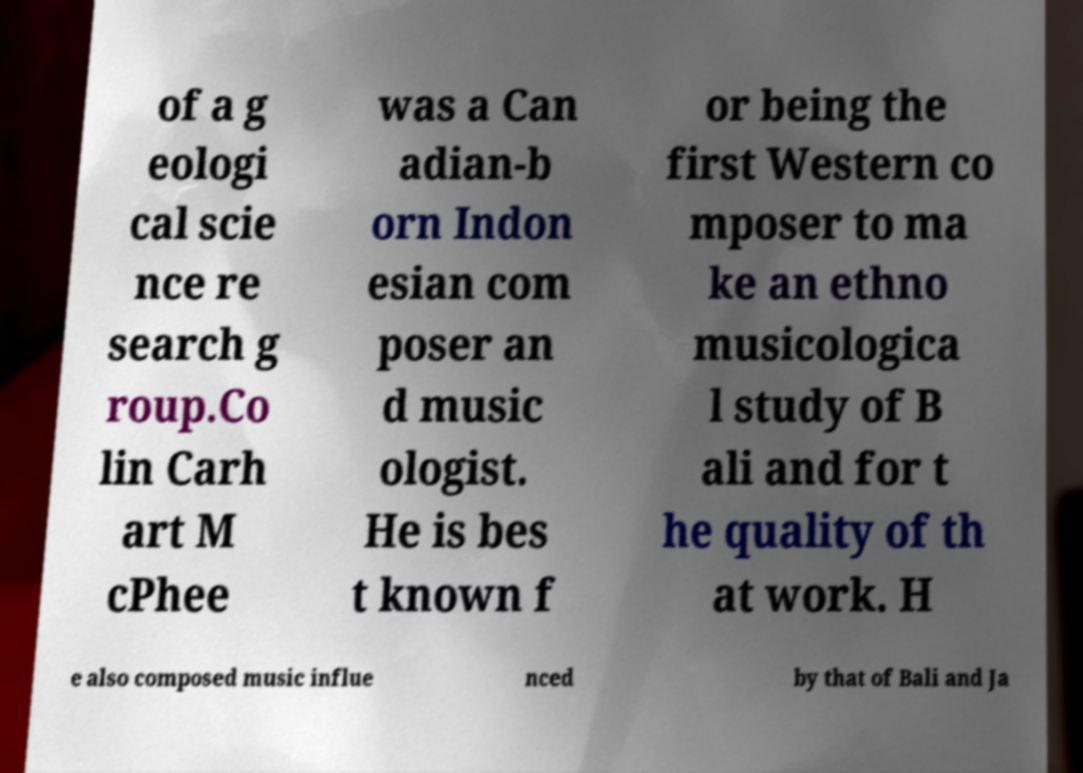What messages or text are displayed in this image? I need them in a readable, typed format. of a g eologi cal scie nce re search g roup.Co lin Carh art M cPhee was a Can adian-b orn Indon esian com poser an d music ologist. He is bes t known f or being the first Western co mposer to ma ke an ethno musicologica l study of B ali and for t he quality of th at work. H e also composed music influe nced by that of Bali and Ja 